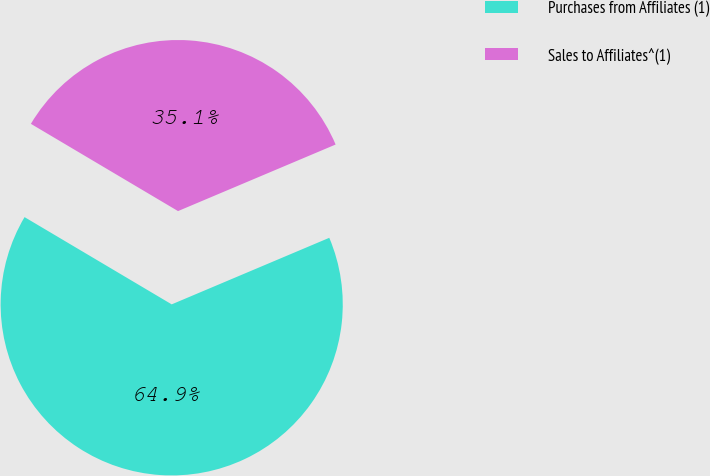<chart> <loc_0><loc_0><loc_500><loc_500><pie_chart><fcel>Purchases from Affiliates (1)<fcel>Sales to Affiliates^(1)<nl><fcel>64.88%<fcel>35.12%<nl></chart> 